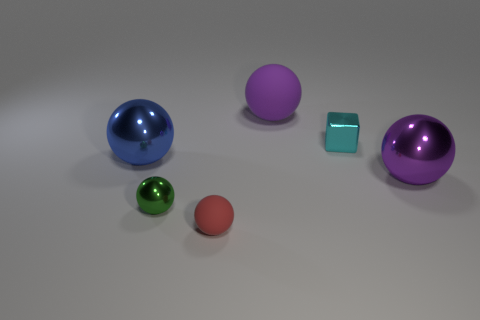What is the color of the object that is both right of the green ball and in front of the purple metallic object?
Provide a succinct answer. Red. What number of purple metallic objects have the same size as the cyan metallic block?
Your response must be concise. 0. What shape is the matte thing that is behind the object left of the green metallic sphere?
Give a very brief answer. Sphere. The matte thing that is behind the big metal object to the right of the tiny metal thing that is behind the big purple shiny sphere is what shape?
Give a very brief answer. Sphere. How many rubber things are the same shape as the big blue metal object?
Provide a short and direct response. 2. There is a small green metal sphere that is behind the red sphere; how many large objects are right of it?
Ensure brevity in your answer.  2. How many shiny things are large purple objects or cubes?
Offer a very short reply. 2. Is there a purple sphere made of the same material as the tiny red sphere?
Your response must be concise. Yes. What number of things are either large purple balls on the left side of the cyan cube or big purple objects behind the cyan metallic block?
Your answer should be very brief. 1. Is the color of the metal ball on the right side of the red thing the same as the big matte thing?
Your answer should be compact. Yes. 